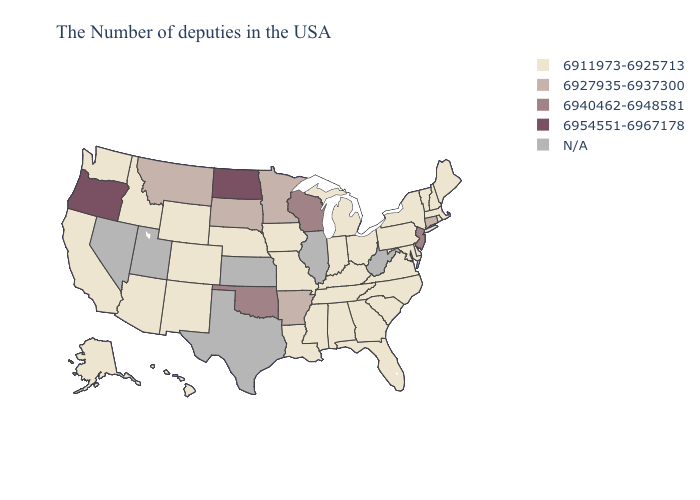What is the value of Nevada?
Short answer required. N/A. Which states have the highest value in the USA?
Be succinct. North Dakota, Oregon. Name the states that have a value in the range 6940462-6948581?
Write a very short answer. New Jersey, Wisconsin, Oklahoma. What is the value of Virginia?
Concise answer only. 6911973-6925713. What is the value of Alaska?
Quick response, please. 6911973-6925713. What is the highest value in the USA?
Answer briefly. 6954551-6967178. What is the value of Virginia?
Keep it brief. 6911973-6925713. Name the states that have a value in the range N/A?
Give a very brief answer. West Virginia, Illinois, Kansas, Texas, Utah, Nevada. Does Oklahoma have the lowest value in the South?
Short answer required. No. What is the value of California?
Be succinct. 6911973-6925713. How many symbols are there in the legend?
Short answer required. 5. Does the map have missing data?
Answer briefly. Yes. What is the value of Kansas?
Concise answer only. N/A. Does Indiana have the lowest value in the USA?
Give a very brief answer. Yes. 